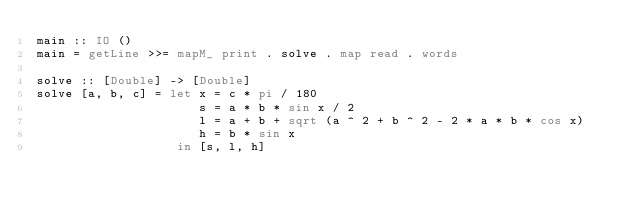Convert code to text. <code><loc_0><loc_0><loc_500><loc_500><_Haskell_>main :: IO ()
main = getLine >>= mapM_ print . solve . map read . words

solve :: [Double] -> [Double]
solve [a, b, c] = let x = c * pi / 180
                      s = a * b * sin x / 2
                      l = a + b + sqrt (a ^ 2 + b ^ 2 - 2 * a * b * cos x)
                      h = b * sin x
                   in [s, l, h]
</code> 